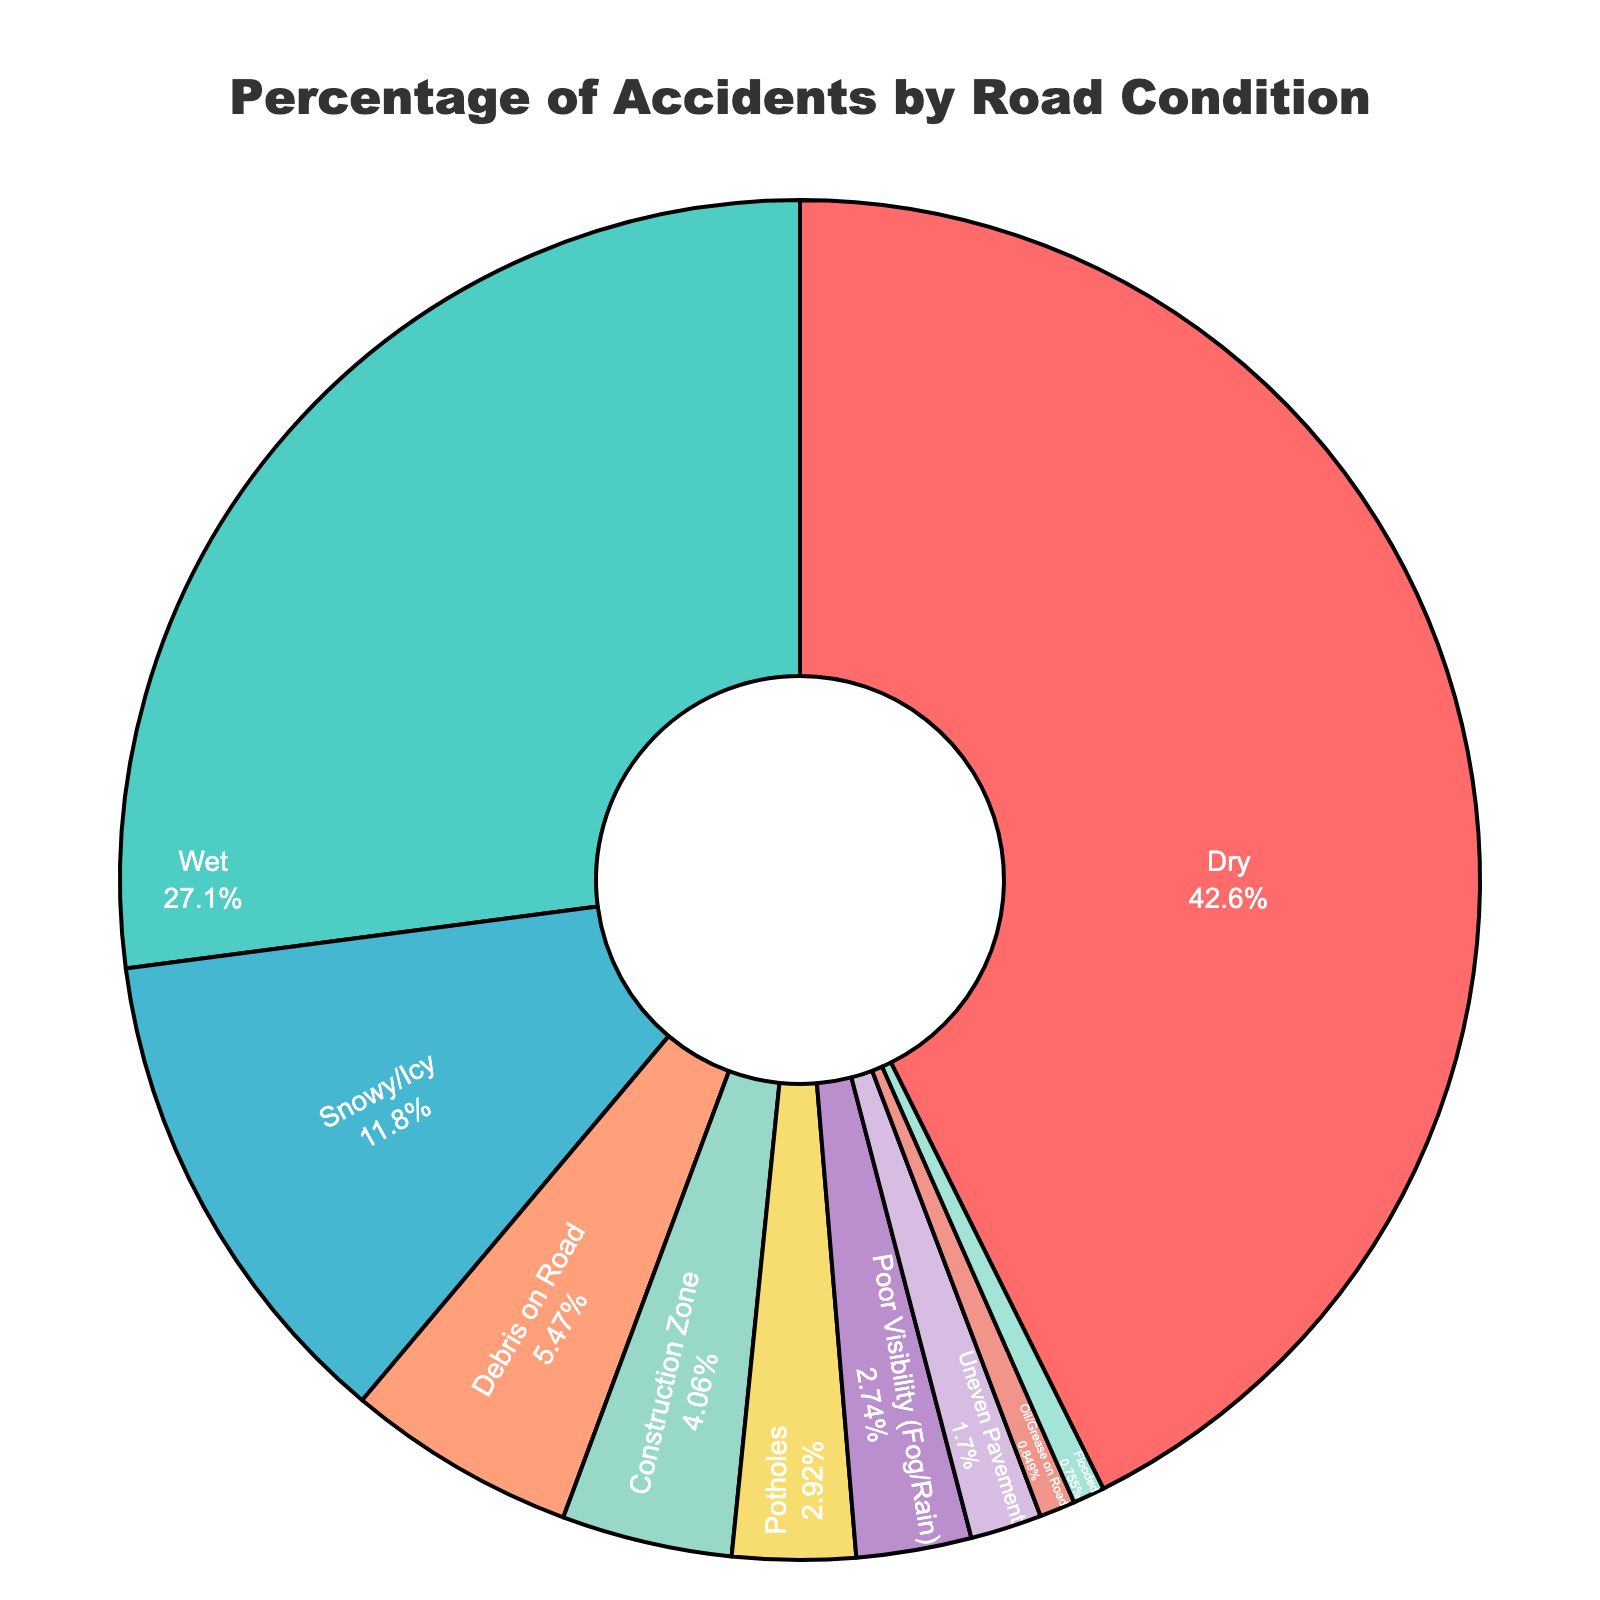What percentage of accidents occur in dry conditions? The figure shows the percentage attributed to different road conditions. The segment labeled "Dry" accounts for 45.2%.
Answer: 45.2% What is the total percentage of accidents occurring in wet and snowy/icy conditions? We need to add the percentages for "Wet" and "Snowy/Icy". That is 28.7% + 12.5%.
Answer: 41.2% Which road condition accounts for the second highest percentage of accidents? The highest is "Dry" at 45.2%. The second highest percentage is "Wet" at 28.7%.
Answer: Wet Are there more accidents due to construction zone conditions or potholes? Compare the percentage values for "Construction Zone" (4.3%) and "Potholes" (3.1%). Construction Zone is higher.
Answer: Construction Zone How does the percentage of accidents on dry roads compare to the sum of accidents due to debris on the road and uneven pavement? Add the percentages for "Debris on Road" and "Uneven Pavement": 5.8% + 1.8% = 7.6%. Compare this to "Dry" at 45.2%.
Answer: Dry is much higher What total percentage of accidents are caused by either poor visibility conditions or flooded roads? Add the percentages for "Poor Visibility (Fog/Rain)" and "Flooded": 2.9% + 0.8%.
Answer: 3.7% Which conditions have a percentage of accidents lower than 5%? Identify and list conditions with percentages less than 5%: "Debris on Road" (5.8%) is too high. Others include "Construction Zone" (4.3%), "Potholes" (3.1%), "Poor Visibility (Fog/Rain)" (2.9%), "Uneven Pavement" (1.8%), "Oil/Grease on Road" (0.9%), and "Flooded" (0.8%).
Answer: Construction Zone, Potholes, Poor Visibility, Uneven Pavement, Oil/Grease on Road, Flooded What is the combined percentage of accidents due to road conditions involving water (wet, poor visibility, or flooded)? Add up percentages for "Wet", "Poor Visibility (Fog/Rain)", and "Flooded": 28.7% + 2.9% + 0.8%.
Answer: 32.4% Which road condition is represented with the smallest percentage? By examining the figure, "Flooded" has the smallest percentage at 0.8%.
Answer: Flooded 